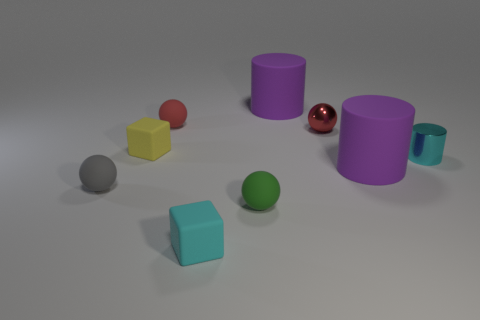Subtract all matte spheres. How many spheres are left? 1 Subtract all purple blocks. How many purple cylinders are left? 2 Subtract 2 cubes. How many cubes are left? 0 Add 1 large yellow spheres. How many objects exist? 10 Subtract all green spheres. How many spheres are left? 3 Subtract all balls. How many objects are left? 5 Add 8 tiny brown cubes. How many tiny brown cubes exist? 8 Subtract 0 brown blocks. How many objects are left? 9 Subtract all cyan spheres. Subtract all purple cubes. How many spheres are left? 4 Subtract all large purple rubber cylinders. Subtract all cylinders. How many objects are left? 4 